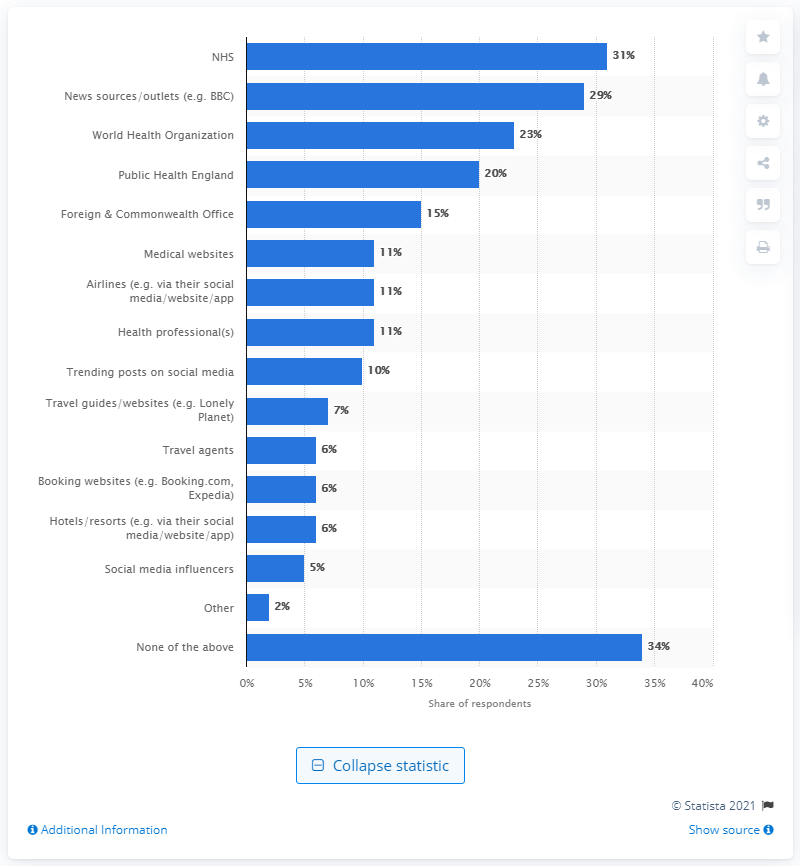Indicate a few pertinent items in this graphic. Nearly one-fifth of respondents in the UK consulted the National Health Service and World Health Organization for advice on foreign travel. In the UK, 29% of people looked at news sources specifically. According to a survey conducted in the UK, 31% of the people consulted the National Health Service and the World Health Organization for advice on foreign travel. 